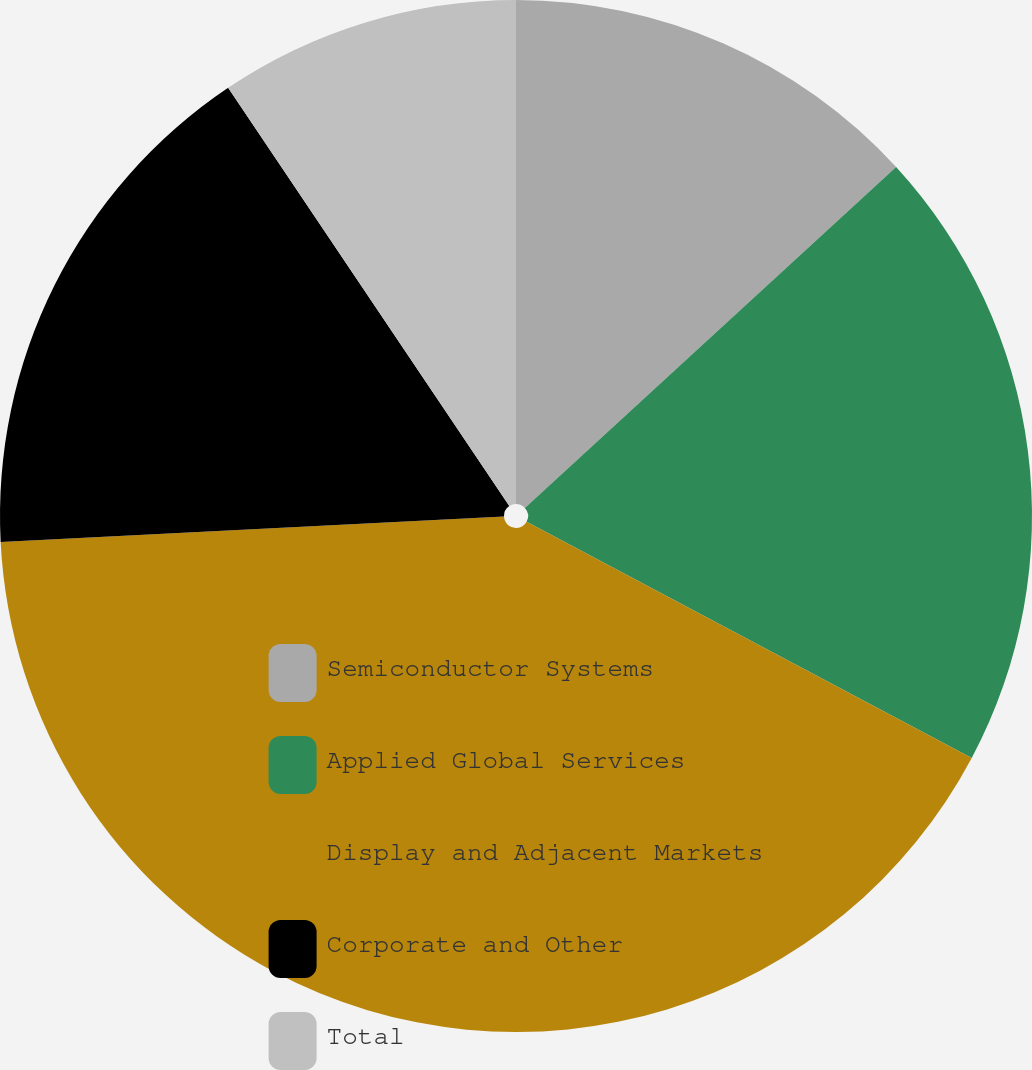<chart> <loc_0><loc_0><loc_500><loc_500><pie_chart><fcel>Semiconductor Systems<fcel>Applied Global Services<fcel>Display and Adjacent Markets<fcel>Corporate and Other<fcel>Total<nl><fcel>13.18%<fcel>19.59%<fcel>41.43%<fcel>16.38%<fcel>9.42%<nl></chart> 